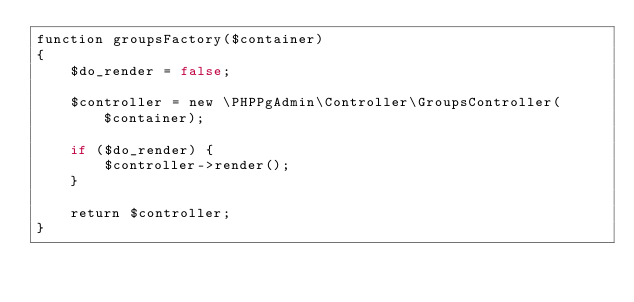<code> <loc_0><loc_0><loc_500><loc_500><_PHP_>function groupsFactory($container)
{
    $do_render = false;

    $controller = new \PHPPgAdmin\Controller\GroupsController($container);

    if ($do_render) {
        $controller->render();
    }

    return $controller;
}
</code> 